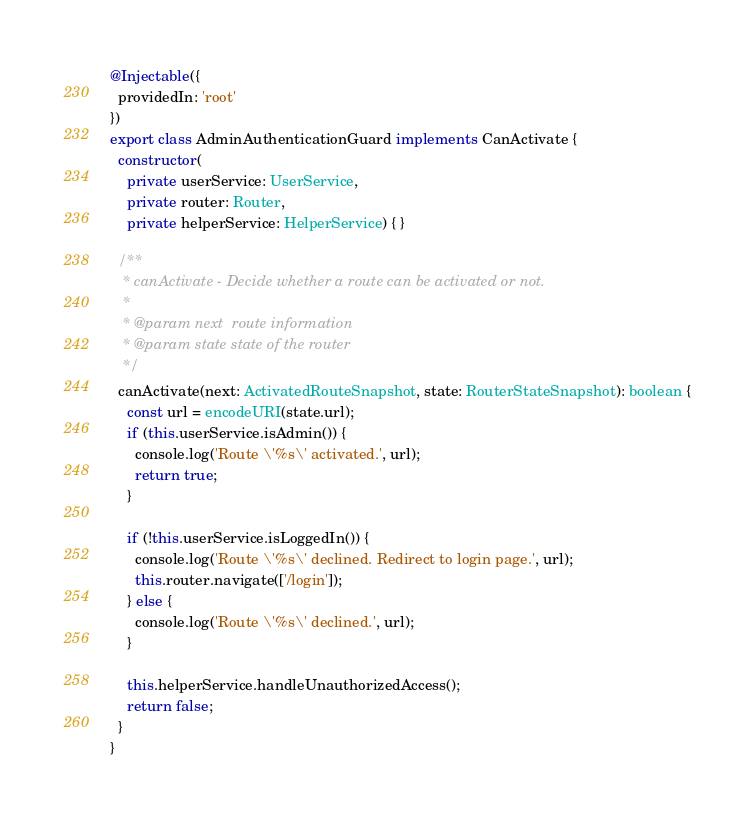Convert code to text. <code><loc_0><loc_0><loc_500><loc_500><_TypeScript_>
@Injectable({
  providedIn: 'root'
})
export class AdminAuthenticationGuard implements CanActivate {
  constructor(
    private userService: UserService,
    private router: Router,
    private helperService: HelperService) { }

  /**
   * canActivate - Decide whether a route can be activated or not.
   *
   * @param next  route information
   * @param state state of the router
   */
  canActivate(next: ActivatedRouteSnapshot, state: RouterStateSnapshot): boolean {
    const url = encodeURI(state.url);
    if (this.userService.isAdmin()) {
      console.log('Route \'%s\' activated.', url);
      return true;
    }

    if (!this.userService.isLoggedIn()) {
      console.log('Route \'%s\' declined. Redirect to login page.', url);
      this.router.navigate(['/login']);
    } else {
      console.log('Route \'%s\' declined.', url);
    }

    this.helperService.handleUnauthorizedAccess();
    return false;
  }
}
</code> 